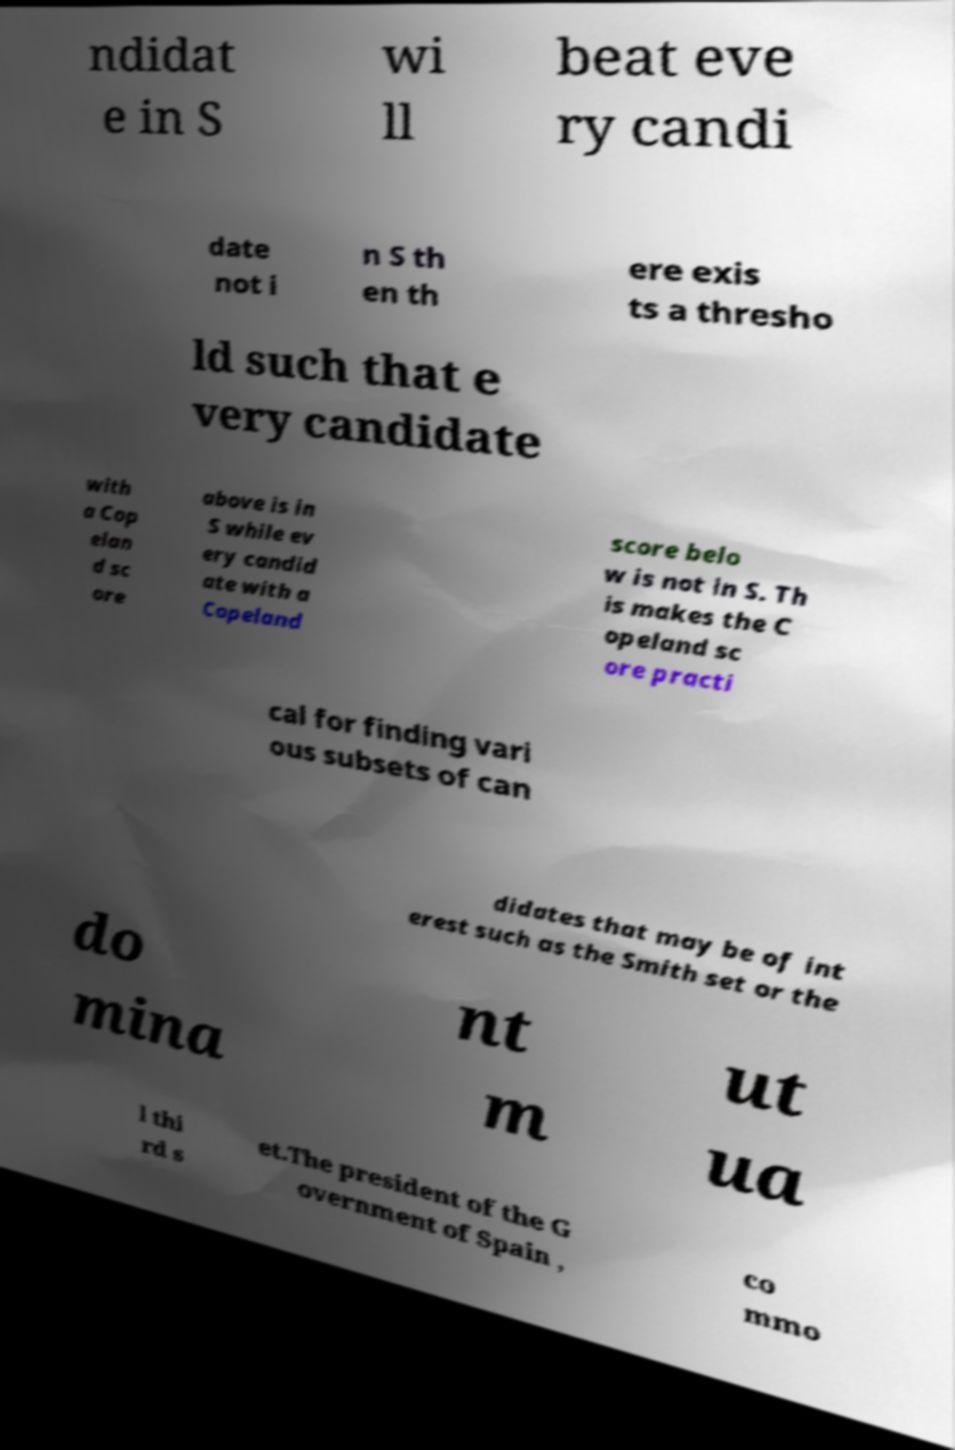Please read and relay the text visible in this image. What does it say? ndidat e in S wi ll beat eve ry candi date not i n S th en th ere exis ts a thresho ld such that e very candidate with a Cop elan d sc ore above is in S while ev ery candid ate with a Copeland score belo w is not in S. Th is makes the C opeland sc ore practi cal for finding vari ous subsets of can didates that may be of int erest such as the Smith set or the do mina nt m ut ua l thi rd s et.The president of the G overnment of Spain , co mmo 